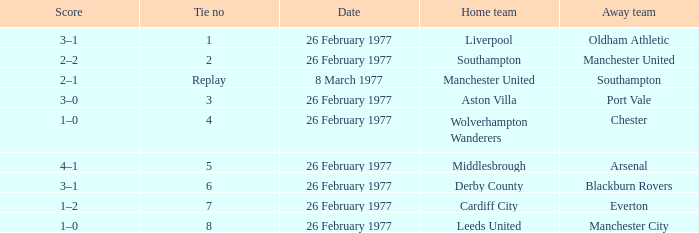Which was the host team that competed against manchester united? Southampton. 